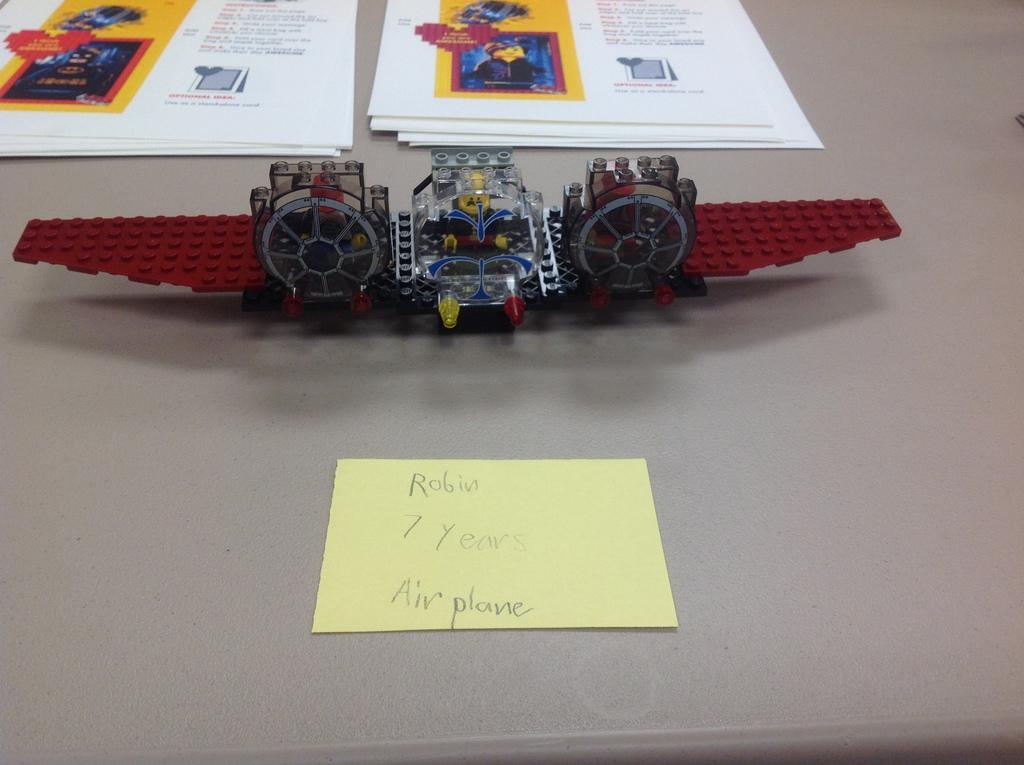Describe this image in one or two sentences. In the center of the image we can see one object. On that object, we can see a toy and papers with some text and some images. 